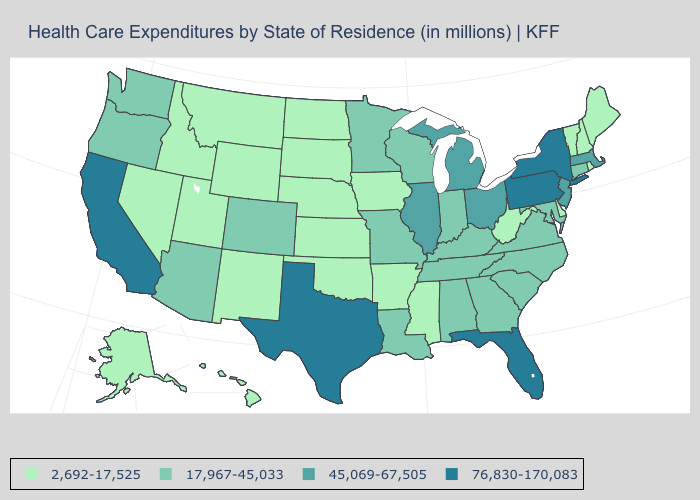Does the first symbol in the legend represent the smallest category?
Quick response, please. Yes. Does the first symbol in the legend represent the smallest category?
Answer briefly. Yes. Is the legend a continuous bar?
Answer briefly. No. Does the first symbol in the legend represent the smallest category?
Answer briefly. Yes. What is the value of Alaska?
Answer briefly. 2,692-17,525. Does Rhode Island have the lowest value in the Northeast?
Write a very short answer. Yes. Name the states that have a value in the range 2,692-17,525?
Keep it brief. Alaska, Arkansas, Delaware, Hawaii, Idaho, Iowa, Kansas, Maine, Mississippi, Montana, Nebraska, Nevada, New Hampshire, New Mexico, North Dakota, Oklahoma, Rhode Island, South Dakota, Utah, Vermont, West Virginia, Wyoming. Does Alaska have the lowest value in the West?
Keep it brief. Yes. What is the value of Mississippi?
Short answer required. 2,692-17,525. What is the value of Montana?
Be succinct. 2,692-17,525. What is the lowest value in the USA?
Give a very brief answer. 2,692-17,525. Which states hav the highest value in the MidWest?
Answer briefly. Illinois, Michigan, Ohio. Does the map have missing data?
Short answer required. No. Which states hav the highest value in the Northeast?
Short answer required. New York, Pennsylvania. Name the states that have a value in the range 17,967-45,033?
Give a very brief answer. Alabama, Arizona, Colorado, Connecticut, Georgia, Indiana, Kentucky, Louisiana, Maryland, Minnesota, Missouri, North Carolina, Oregon, South Carolina, Tennessee, Virginia, Washington, Wisconsin. 